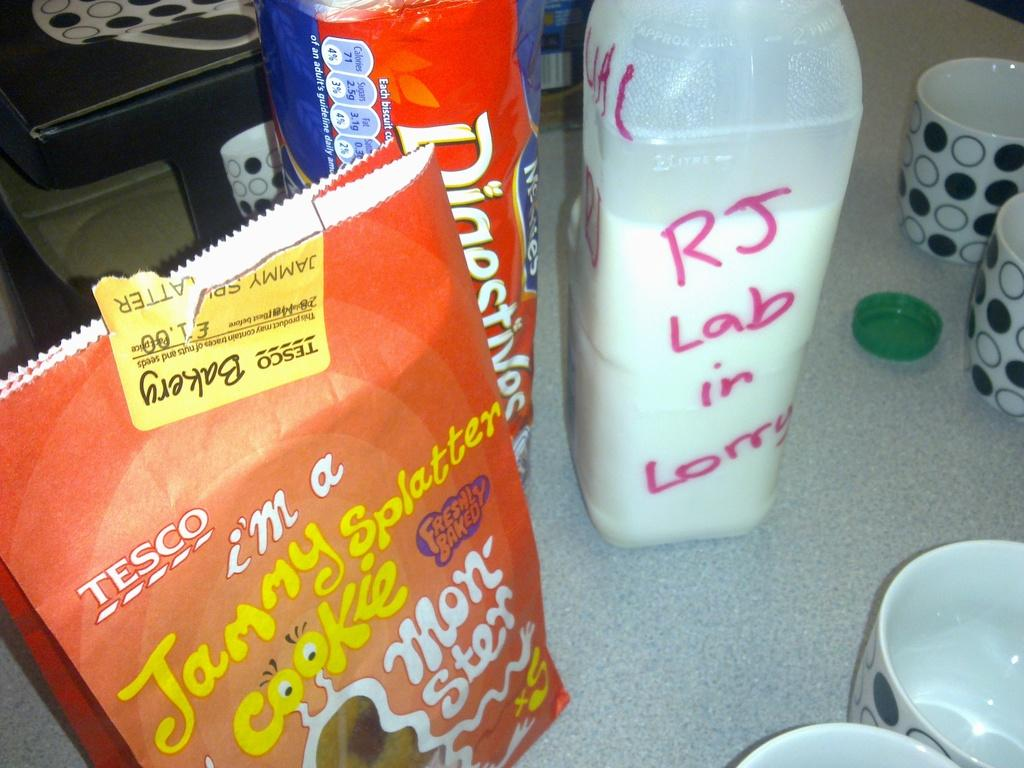<image>
Render a clear and concise summary of the photo. the name RJ is on a white bottle 